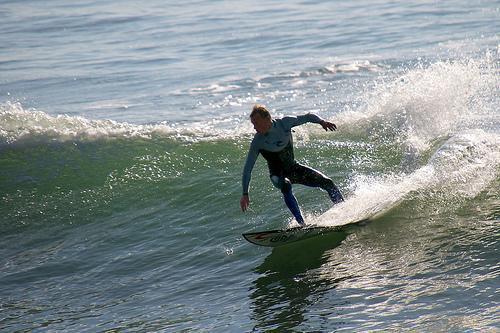How many people?
Give a very brief answer. 1. 